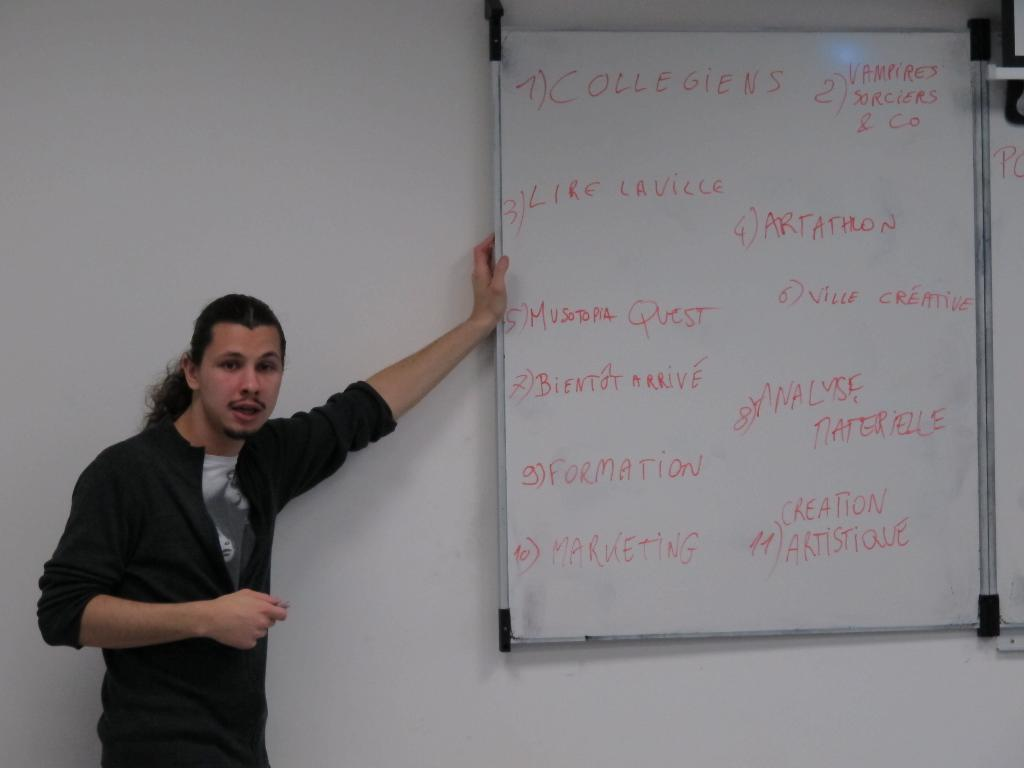<image>
Offer a succinct explanation of the picture presented. Person standing next to a white board which says "Collegiens" on the top. 